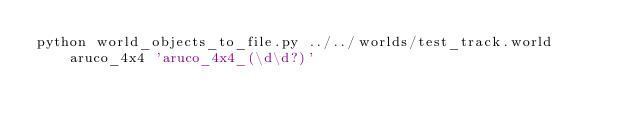<code> <loc_0><loc_0><loc_500><loc_500><_Bash_>python world_objects_to_file.py ../../worlds/test_track.world aruco_4x4 'aruco_4x4_(\d\d?)'
</code> 